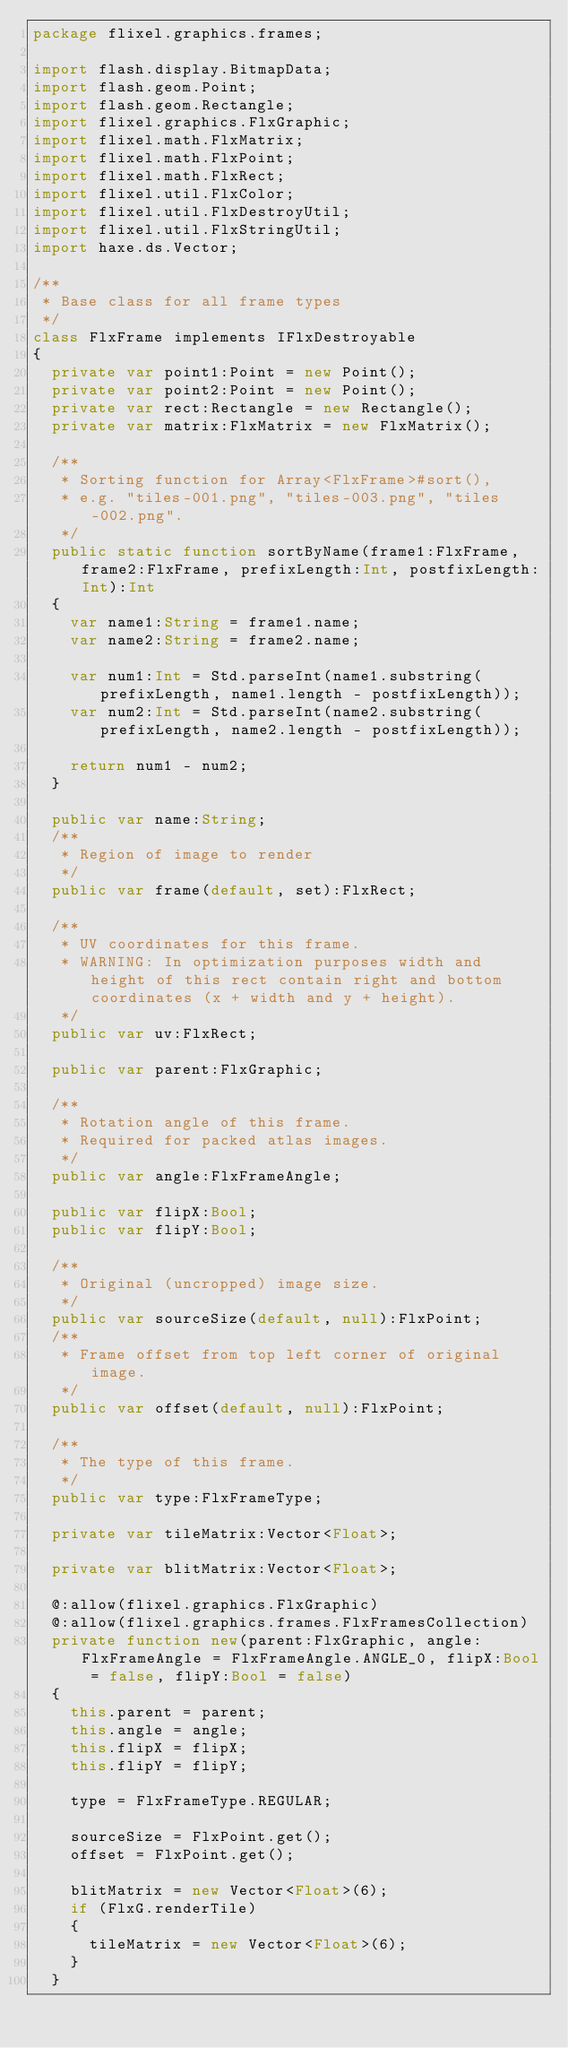<code> <loc_0><loc_0><loc_500><loc_500><_Haxe_>package flixel.graphics.frames;

import flash.display.BitmapData;
import flash.geom.Point;
import flash.geom.Rectangle;
import flixel.graphics.FlxGraphic;
import flixel.math.FlxMatrix;
import flixel.math.FlxPoint;
import flixel.math.FlxRect;
import flixel.util.FlxColor;
import flixel.util.FlxDestroyUtil;
import flixel.util.FlxStringUtil;
import haxe.ds.Vector;

/**
 * Base class for all frame types
 */
class FlxFrame implements IFlxDestroyable
{
	private var point1:Point = new Point();
	private var point2:Point = new Point();
	private var rect:Rectangle = new Rectangle();
	private var matrix:FlxMatrix = new FlxMatrix();
	
	/**
	 * Sorting function for Array<FlxFrame>#sort(),
	 * e.g. "tiles-001.png", "tiles-003.png", "tiles-002.png".
	 */
	public static function sortByName(frame1:FlxFrame, frame2:FlxFrame, prefixLength:Int, postfixLength:Int):Int
	{
		var name1:String = frame1.name;
		var name2:String = frame2.name;
		
		var num1:Int = Std.parseInt(name1.substring(prefixLength, name1.length - postfixLength));
		var num2:Int = Std.parseInt(name2.substring(prefixLength, name2.length - postfixLength));
		
		return num1 - num2;
	}
	
	public var name:String;
	/**
	 * Region of image to render
	 */
	public var frame(default, set):FlxRect;
	
	/**
	 * UV coordinates for this frame.
	 * WARNING: In optimization purposes width and height of this rect contain right and bottom coordinates (x + width and y + height).
	 */
	public var uv:FlxRect;
	
	public var parent:FlxGraphic;
	
	/**
	 * Rotation angle of this frame. 
	 * Required for packed atlas images.
	 */
	public var angle:FlxFrameAngle;
	
	public var flipX:Bool;
	public var flipY:Bool;
	
	/**
	 * Original (uncropped) image size.
	 */
	public var sourceSize(default, null):FlxPoint;
	/**
	 * Frame offset from top left corner of original image.
	 */
	public var offset(default, null):FlxPoint;
	
	/**
	 * The type of this frame.
	 */
	public var type:FlxFrameType;
	
	private var tileMatrix:Vector<Float>;
	
	private var blitMatrix:Vector<Float>;
	
	@:allow(flixel.graphics.FlxGraphic)
	@:allow(flixel.graphics.frames.FlxFramesCollection)
	private function new(parent:FlxGraphic, angle:FlxFrameAngle = FlxFrameAngle.ANGLE_0, flipX:Bool = false, flipY:Bool = false)
	{
		this.parent = parent;
		this.angle = angle;
		this.flipX = flipX;
		this.flipY = flipY;
		
		type = FlxFrameType.REGULAR;
		
		sourceSize = FlxPoint.get();
		offset = FlxPoint.get();
		
		blitMatrix = new Vector<Float>(6);
		if (FlxG.renderTile)
		{
			tileMatrix = new Vector<Float>(6);
		}
	}
	</code> 